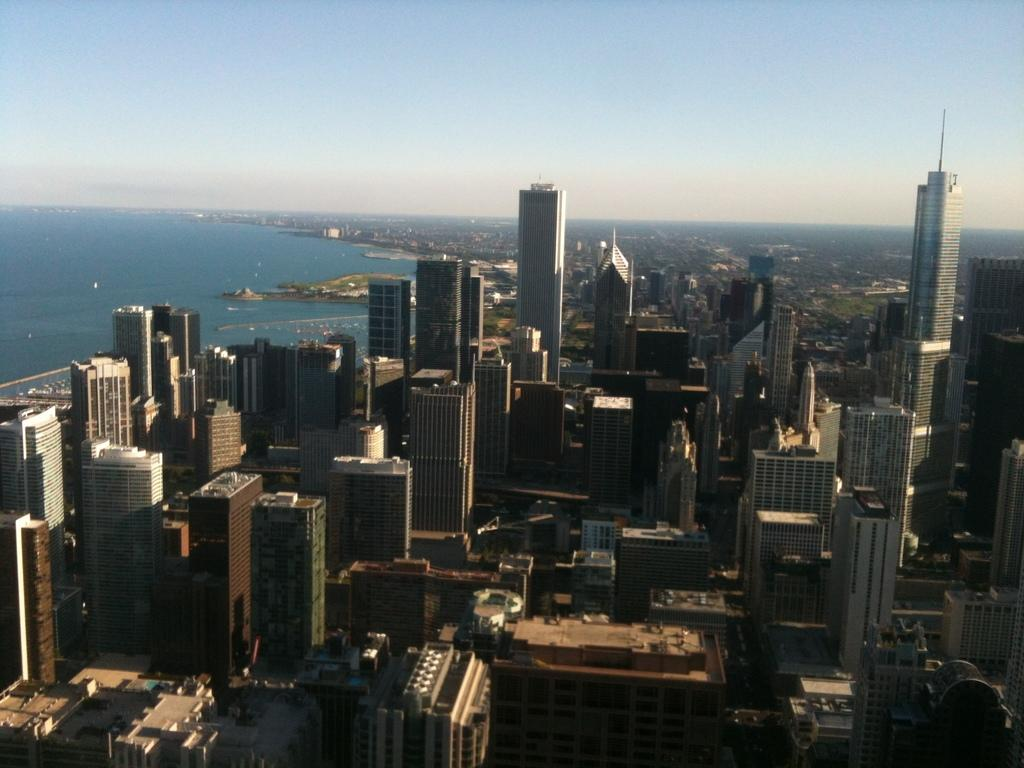What type of structures can be seen in the image? There are many buildings in the image. What is located on the left side of the image? There is water on the left side of the image. What can be seen in the background of the image? The sky is visible in the background of the image. Can you see a worm crawling on the stage in the image? There is no stage or worm present in the image. What type of plane is flying in the image? There is no plane visible in the image; it only features buildings, water, and the sky. 